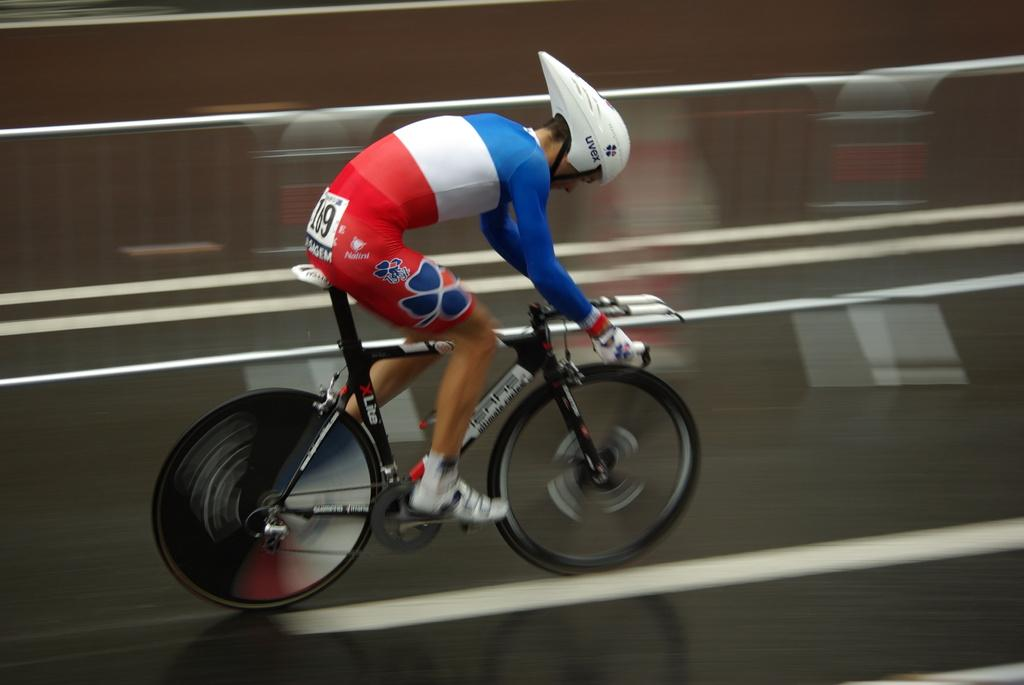Who is the person in the image? There is a man in the image. What is the man doing in the image? The man is riding a bicycle in the image. Where is the man located in the image? The man is on the road in the image. What is the man wearing in the image? The man is wearing a sport dress and a helmet in the image. What type of can does the man use to cook in the image? There is no can or cooking activity present in the image. What type of connection does the man have with the bicycle in the image? The man is riding the bicycle in the image, which implies a connection through the act of riding. However, the specific type of connection is not mentioned in the facts provided. 